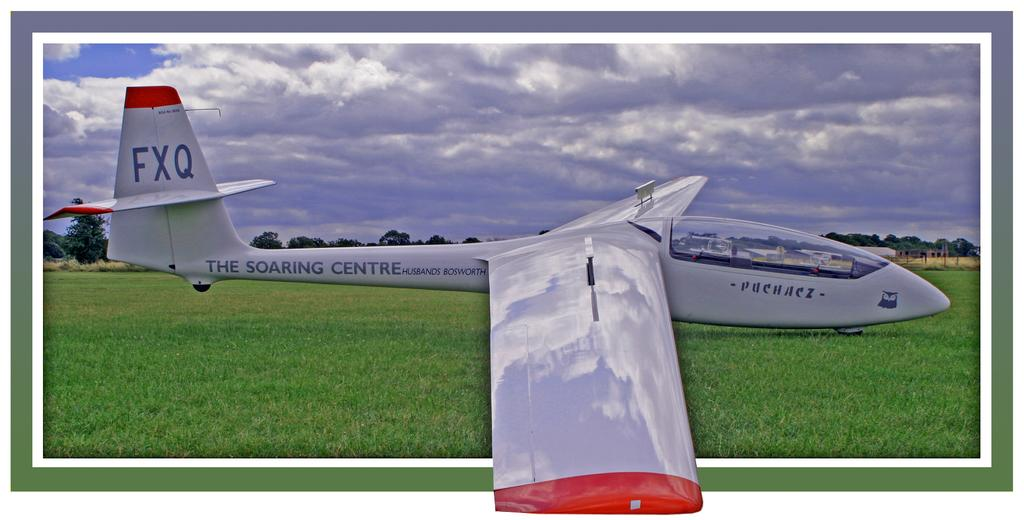<image>
Summarize the visual content of the image. a grey and red airplane with large wings and fxq labeled on the back wing. 